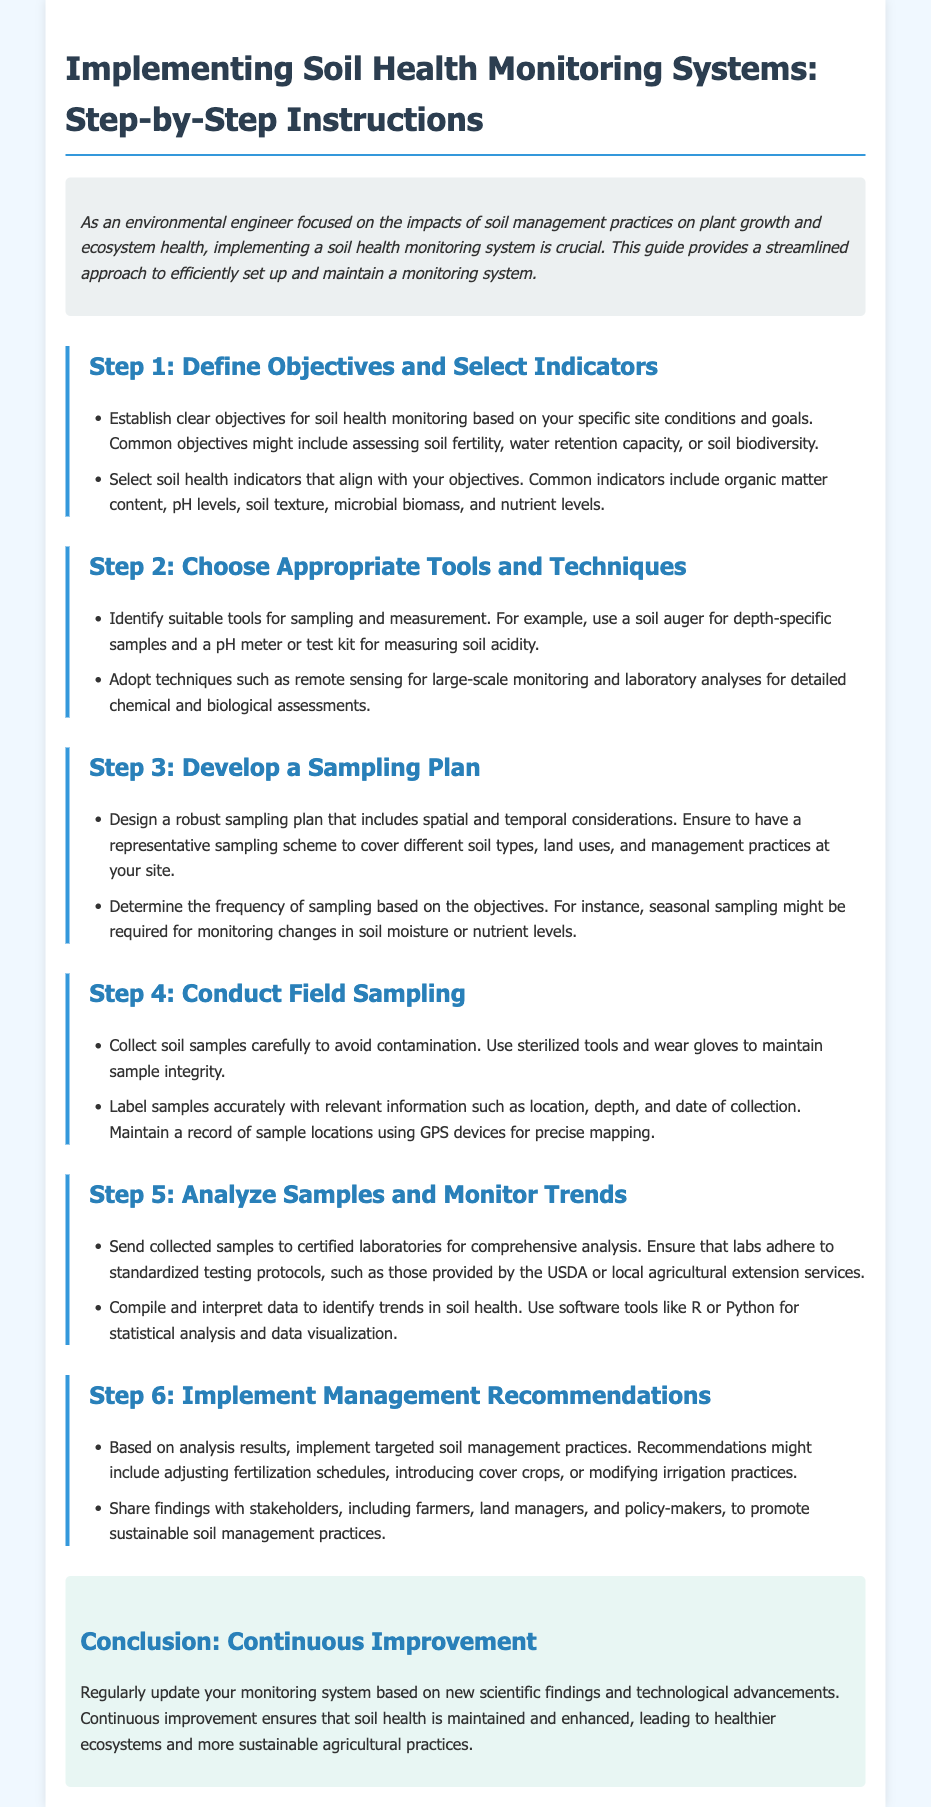what is the title of the guide? The title of the guide is provided in the document's header section.
Answer: Implementing Soil Health Monitoring Systems: Step-by-Step Instructions what is the first step in implementing soil health monitoring systems? The document outlines a series of steps, with the first step clearly labeled.
Answer: Define Objectives and Select Indicators what are two common soil health indicators mentioned? The document lists several indicators under step one, making it clear what to focus on.
Answer: organic matter content, pH levels how should soil samples be labeled? The guide provides specific instructions regarding sample labeling.
Answer: with relevant information such as location, depth, and date of collection what is one technique suggested for large-scale monitoring? The document mentions techniques suitable for different scales of monitoring systems.
Answer: remote sensing how often should sampling be conducted for monitoring changes in soil moisture? The document suggests a specific frequency based on objectives, indicating a seasonal requirement.
Answer: seasonal what should be done based on analysis results? The guide provides recommendations for actions following the soil sample analysis.
Answer: implement targeted soil management practices which software tools are mentioned for data analysis? The document references specific software tools that can assist in analyzing soil health data.
Answer: R or Python what is emphasized in the conclusion section of the guide? The final section of the document highlights a key concept related to the monitoring system.
Answer: Continuous Improvement 